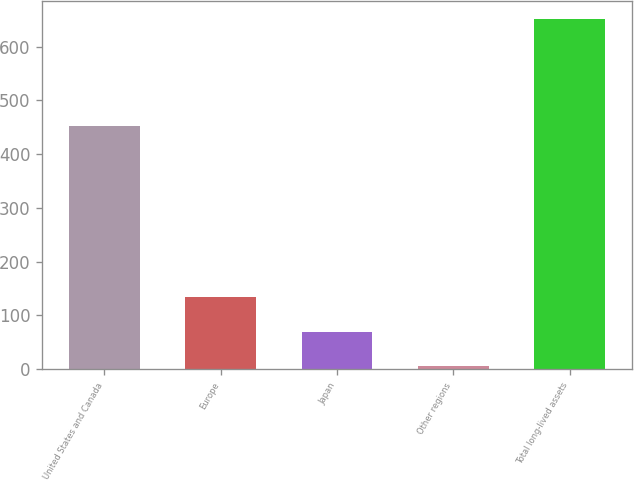<chart> <loc_0><loc_0><loc_500><loc_500><bar_chart><fcel>United States and Canada<fcel>Europe<fcel>Japan<fcel>Other regions<fcel>Total long-lived assets<nl><fcel>452.8<fcel>134.48<fcel>69.84<fcel>5.2<fcel>651.6<nl></chart> 